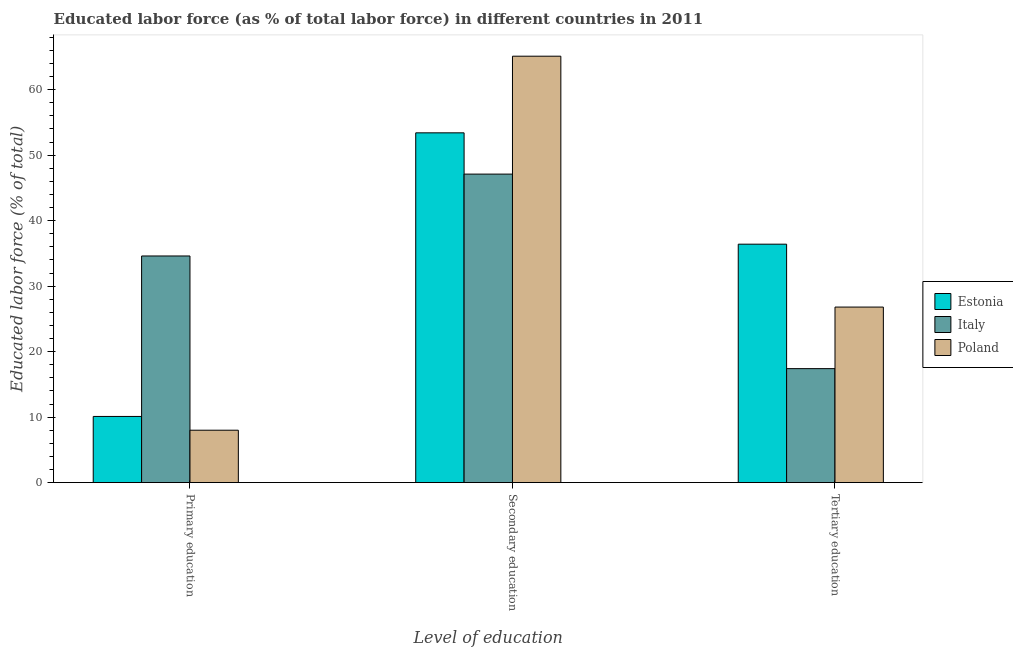How many groups of bars are there?
Your answer should be very brief. 3. Are the number of bars per tick equal to the number of legend labels?
Your answer should be compact. Yes. Are the number of bars on each tick of the X-axis equal?
Give a very brief answer. Yes. How many bars are there on the 3rd tick from the right?
Provide a succinct answer. 3. What is the label of the 3rd group of bars from the left?
Your answer should be very brief. Tertiary education. What is the percentage of labor force who received primary education in Estonia?
Give a very brief answer. 10.1. Across all countries, what is the maximum percentage of labor force who received tertiary education?
Offer a terse response. 36.4. Across all countries, what is the minimum percentage of labor force who received tertiary education?
Your answer should be very brief. 17.4. In which country was the percentage of labor force who received tertiary education maximum?
Ensure brevity in your answer.  Estonia. In which country was the percentage of labor force who received primary education minimum?
Offer a terse response. Poland. What is the total percentage of labor force who received secondary education in the graph?
Offer a terse response. 165.6. What is the difference between the percentage of labor force who received secondary education in Poland and that in Italy?
Give a very brief answer. 18. What is the difference between the percentage of labor force who received primary education in Italy and the percentage of labor force who received secondary education in Poland?
Your answer should be very brief. -30.5. What is the average percentage of labor force who received primary education per country?
Your answer should be very brief. 17.57. What is the difference between the percentage of labor force who received secondary education and percentage of labor force who received primary education in Poland?
Your response must be concise. 57.1. What is the ratio of the percentage of labor force who received secondary education in Estonia to that in Poland?
Give a very brief answer. 0.82. Is the percentage of labor force who received tertiary education in Italy less than that in Poland?
Provide a short and direct response. Yes. What is the difference between the highest and the second highest percentage of labor force who received tertiary education?
Offer a terse response. 9.6. What is the difference between the highest and the lowest percentage of labor force who received primary education?
Make the answer very short. 26.6. Is it the case that in every country, the sum of the percentage of labor force who received primary education and percentage of labor force who received secondary education is greater than the percentage of labor force who received tertiary education?
Give a very brief answer. Yes. How many countries are there in the graph?
Ensure brevity in your answer.  3. What is the difference between two consecutive major ticks on the Y-axis?
Provide a succinct answer. 10. Does the graph contain grids?
Give a very brief answer. No. How are the legend labels stacked?
Keep it short and to the point. Vertical. What is the title of the graph?
Make the answer very short. Educated labor force (as % of total labor force) in different countries in 2011. What is the label or title of the X-axis?
Ensure brevity in your answer.  Level of education. What is the label or title of the Y-axis?
Keep it short and to the point. Educated labor force (% of total). What is the Educated labor force (% of total) in Estonia in Primary education?
Your answer should be very brief. 10.1. What is the Educated labor force (% of total) in Italy in Primary education?
Ensure brevity in your answer.  34.6. What is the Educated labor force (% of total) of Estonia in Secondary education?
Make the answer very short. 53.4. What is the Educated labor force (% of total) in Italy in Secondary education?
Provide a short and direct response. 47.1. What is the Educated labor force (% of total) of Poland in Secondary education?
Provide a short and direct response. 65.1. What is the Educated labor force (% of total) in Estonia in Tertiary education?
Ensure brevity in your answer.  36.4. What is the Educated labor force (% of total) in Italy in Tertiary education?
Give a very brief answer. 17.4. What is the Educated labor force (% of total) of Poland in Tertiary education?
Your response must be concise. 26.8. Across all Level of education, what is the maximum Educated labor force (% of total) of Estonia?
Make the answer very short. 53.4. Across all Level of education, what is the maximum Educated labor force (% of total) in Italy?
Ensure brevity in your answer.  47.1. Across all Level of education, what is the maximum Educated labor force (% of total) of Poland?
Your answer should be compact. 65.1. Across all Level of education, what is the minimum Educated labor force (% of total) in Estonia?
Provide a short and direct response. 10.1. Across all Level of education, what is the minimum Educated labor force (% of total) in Italy?
Provide a short and direct response. 17.4. Across all Level of education, what is the minimum Educated labor force (% of total) of Poland?
Your response must be concise. 8. What is the total Educated labor force (% of total) in Estonia in the graph?
Your response must be concise. 99.9. What is the total Educated labor force (% of total) in Italy in the graph?
Provide a succinct answer. 99.1. What is the total Educated labor force (% of total) in Poland in the graph?
Your answer should be compact. 99.9. What is the difference between the Educated labor force (% of total) in Estonia in Primary education and that in Secondary education?
Give a very brief answer. -43.3. What is the difference between the Educated labor force (% of total) of Poland in Primary education and that in Secondary education?
Ensure brevity in your answer.  -57.1. What is the difference between the Educated labor force (% of total) in Estonia in Primary education and that in Tertiary education?
Keep it short and to the point. -26.3. What is the difference between the Educated labor force (% of total) of Poland in Primary education and that in Tertiary education?
Your answer should be very brief. -18.8. What is the difference between the Educated labor force (% of total) in Estonia in Secondary education and that in Tertiary education?
Your response must be concise. 17. What is the difference between the Educated labor force (% of total) in Italy in Secondary education and that in Tertiary education?
Your answer should be very brief. 29.7. What is the difference between the Educated labor force (% of total) of Poland in Secondary education and that in Tertiary education?
Keep it short and to the point. 38.3. What is the difference between the Educated labor force (% of total) of Estonia in Primary education and the Educated labor force (% of total) of Italy in Secondary education?
Make the answer very short. -37. What is the difference between the Educated labor force (% of total) of Estonia in Primary education and the Educated labor force (% of total) of Poland in Secondary education?
Your answer should be compact. -55. What is the difference between the Educated labor force (% of total) of Italy in Primary education and the Educated labor force (% of total) of Poland in Secondary education?
Your answer should be compact. -30.5. What is the difference between the Educated labor force (% of total) in Estonia in Primary education and the Educated labor force (% of total) in Italy in Tertiary education?
Keep it short and to the point. -7.3. What is the difference between the Educated labor force (% of total) in Estonia in Primary education and the Educated labor force (% of total) in Poland in Tertiary education?
Your answer should be compact. -16.7. What is the difference between the Educated labor force (% of total) in Estonia in Secondary education and the Educated labor force (% of total) in Italy in Tertiary education?
Your answer should be compact. 36. What is the difference between the Educated labor force (% of total) of Estonia in Secondary education and the Educated labor force (% of total) of Poland in Tertiary education?
Your answer should be compact. 26.6. What is the difference between the Educated labor force (% of total) in Italy in Secondary education and the Educated labor force (% of total) in Poland in Tertiary education?
Ensure brevity in your answer.  20.3. What is the average Educated labor force (% of total) of Estonia per Level of education?
Ensure brevity in your answer.  33.3. What is the average Educated labor force (% of total) in Italy per Level of education?
Provide a succinct answer. 33.03. What is the average Educated labor force (% of total) in Poland per Level of education?
Make the answer very short. 33.3. What is the difference between the Educated labor force (% of total) in Estonia and Educated labor force (% of total) in Italy in Primary education?
Keep it short and to the point. -24.5. What is the difference between the Educated labor force (% of total) of Italy and Educated labor force (% of total) of Poland in Primary education?
Your answer should be compact. 26.6. What is the difference between the Educated labor force (% of total) of Estonia and Educated labor force (% of total) of Poland in Secondary education?
Offer a very short reply. -11.7. What is the difference between the Educated labor force (% of total) of Estonia and Educated labor force (% of total) of Poland in Tertiary education?
Provide a short and direct response. 9.6. What is the difference between the Educated labor force (% of total) in Italy and Educated labor force (% of total) in Poland in Tertiary education?
Your response must be concise. -9.4. What is the ratio of the Educated labor force (% of total) of Estonia in Primary education to that in Secondary education?
Give a very brief answer. 0.19. What is the ratio of the Educated labor force (% of total) of Italy in Primary education to that in Secondary education?
Offer a very short reply. 0.73. What is the ratio of the Educated labor force (% of total) of Poland in Primary education to that in Secondary education?
Your answer should be compact. 0.12. What is the ratio of the Educated labor force (% of total) of Estonia in Primary education to that in Tertiary education?
Make the answer very short. 0.28. What is the ratio of the Educated labor force (% of total) in Italy in Primary education to that in Tertiary education?
Ensure brevity in your answer.  1.99. What is the ratio of the Educated labor force (% of total) of Poland in Primary education to that in Tertiary education?
Give a very brief answer. 0.3. What is the ratio of the Educated labor force (% of total) of Estonia in Secondary education to that in Tertiary education?
Make the answer very short. 1.47. What is the ratio of the Educated labor force (% of total) in Italy in Secondary education to that in Tertiary education?
Offer a very short reply. 2.71. What is the ratio of the Educated labor force (% of total) of Poland in Secondary education to that in Tertiary education?
Ensure brevity in your answer.  2.43. What is the difference between the highest and the second highest Educated labor force (% of total) in Estonia?
Offer a terse response. 17. What is the difference between the highest and the second highest Educated labor force (% of total) of Poland?
Ensure brevity in your answer.  38.3. What is the difference between the highest and the lowest Educated labor force (% of total) of Estonia?
Offer a terse response. 43.3. What is the difference between the highest and the lowest Educated labor force (% of total) in Italy?
Offer a very short reply. 29.7. What is the difference between the highest and the lowest Educated labor force (% of total) in Poland?
Make the answer very short. 57.1. 